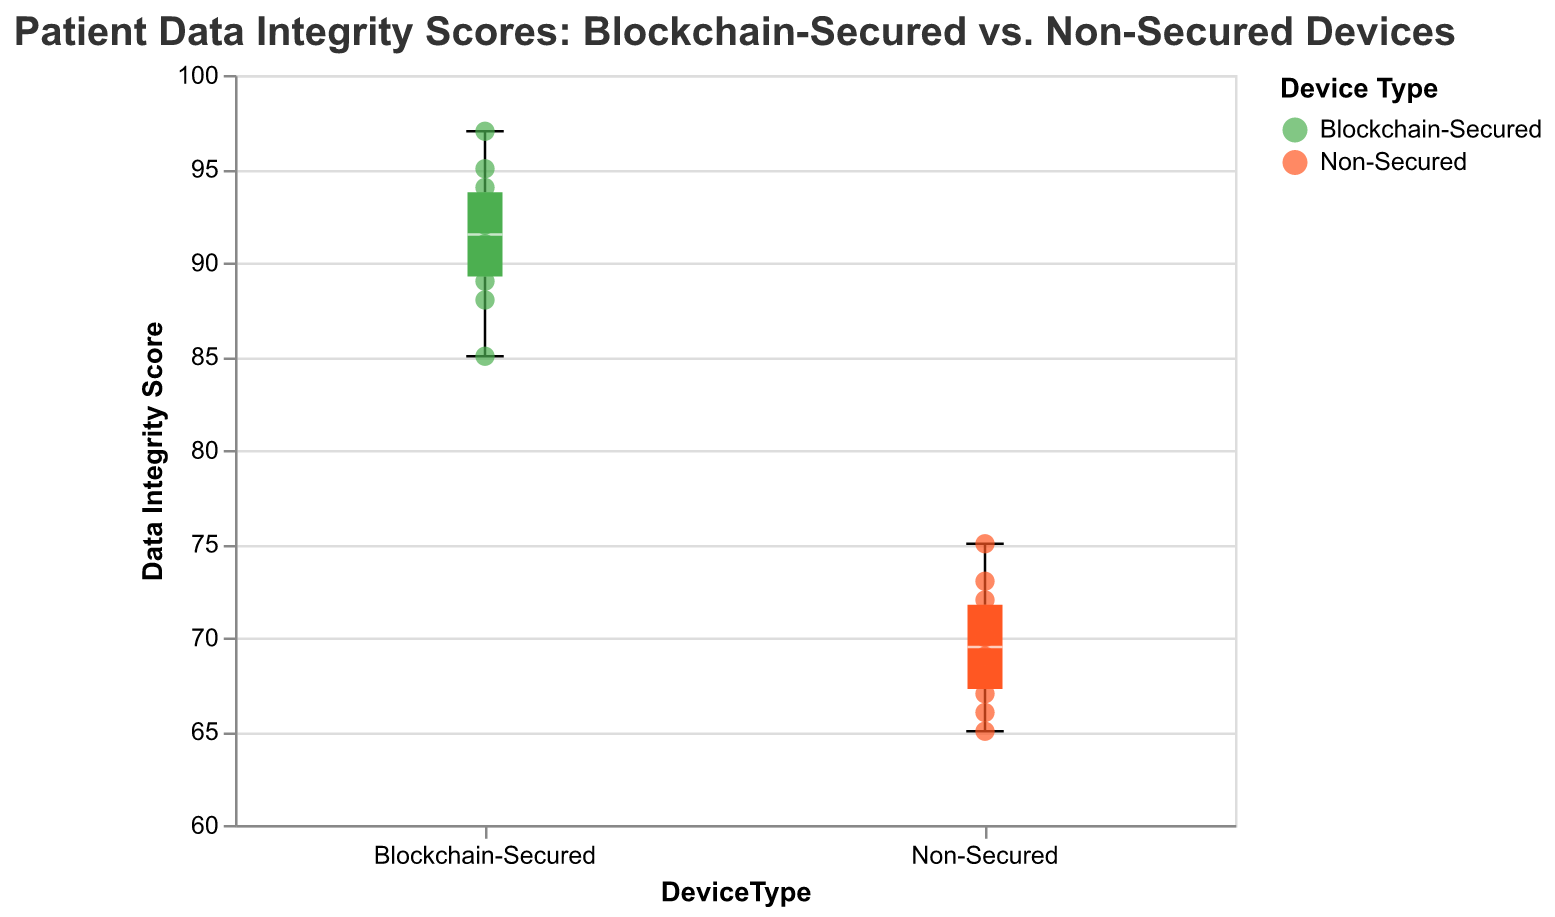What is the title of the figure? The title of the figure is usually placed at the top center. By observing the figure, you can see the text that summarizes the chart.
Answer: Patient Data Integrity Scores: Blockchain-Secured vs. Non-Secured Devices What colors represent Blockchain-Secured and Non-Secured devices? By examining the colors used in the figure, we notice that the box plots and scatter points for Blockchain-Secured devices are in one color and for Non-Secured devices in another. The figure legend confirms these colors.
Answer: Blockchain-Secured is green, Non-Secured is orange How many data points are there for each device type? By counting the individual scatter points in the figure for each device type, we can determine the number of data points.
Answer: 10 data points for each device type What's the range of Data Integrity Scores for Blockchain-Secured devices? The range is defined as the difference between the maximum and minimum values. For Blockchain-Secured devices, the box plot shows these values.
Answer: The range is 85 to 97 What is the median Data Integrity Score for Non-Secured devices? The median value is marked by a line inside the box of the box plot. For Non-Secured devices, we can find this value by observing the box plot.
Answer: The median score is 69 Which device type has a higher maximum Data Integrity Score? By comparing the maximum values (top whiskers) of both device types, we can see which type has a higher maximum score.
Answer: Blockchain-Secured devices What is the interquartile range (IQR) of Data Integrity Scores for Blockchain-Secured devices? The IQR is the range between the first quartile (Q1) and the third quartile (Q3). For Blockchain-Secured devices, we look at the box plot to find the values of Q1 and Q3, and then calculate the difference.
Answer: IQR is 89 to 94 Compare the median Data Integrity Scores of Blockchain-Secured and Non-Secured devices. Which is higher and by how much? To compare medians, observe the line inside each box plot's box indicating the median. For Blockchain-Secured it’s 91, and for Non-Secured it’s 69. Subtract the Non-Secured median from the Blockchain-Secured median.
Answer: Blockchain-Secured by 22 points Is there any overlap in the Data Integrity Scores between Blockchain-Secured and Non-Secured devices? Overlaps can be detected by comparing the ranges (min-to-max) of both box plots. If any part of these ranges coincides, there is an overlap.
Answer: No, there is no overlap What outliers, if any, are present in the Data Integrity Scores? Outliers would be marked as individual points outside the whiskers of the box plot. By examining both box plots, we can see if there are any such points.
Answer: There are no outliers 